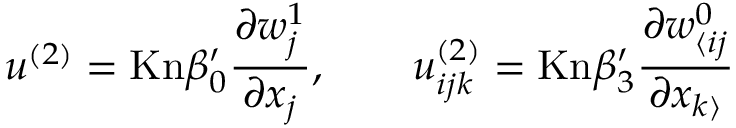Convert formula to latex. <formula><loc_0><loc_0><loc_500><loc_500>u ^ { ( 2 ) } = K n \beta _ { 0 } ^ { \prime } \frac { \partial w _ { j } ^ { 1 } } { \partial x _ { j } } , \quad u _ { i j k } ^ { ( 2 ) } = K n \beta _ { 3 } ^ { \prime } \frac { \partial w _ { \langle i j } ^ { 0 } } { \partial x _ { k \rangle } }</formula> 